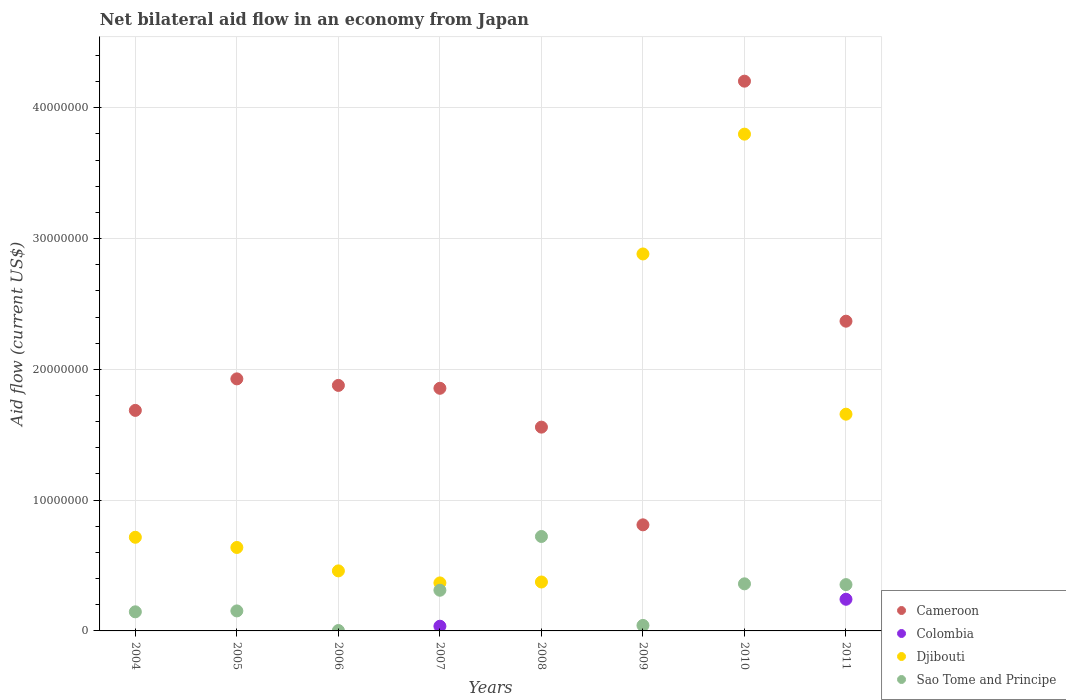Is the number of dotlines equal to the number of legend labels?
Your response must be concise. No. What is the net bilateral aid flow in Djibouti in 2005?
Give a very brief answer. 6.38e+06. Across all years, what is the maximum net bilateral aid flow in Djibouti?
Your answer should be compact. 3.80e+07. Across all years, what is the minimum net bilateral aid flow in Cameroon?
Provide a short and direct response. 8.11e+06. What is the total net bilateral aid flow in Cameroon in the graph?
Keep it short and to the point. 1.63e+08. What is the difference between the net bilateral aid flow in Djibouti in 2009 and that in 2010?
Keep it short and to the point. -9.16e+06. What is the difference between the net bilateral aid flow in Djibouti in 2005 and the net bilateral aid flow in Colombia in 2010?
Provide a succinct answer. 6.38e+06. What is the average net bilateral aid flow in Djibouti per year?
Offer a terse response. 1.36e+07. In the year 2006, what is the difference between the net bilateral aid flow in Djibouti and net bilateral aid flow in Cameroon?
Your response must be concise. -1.42e+07. What is the ratio of the net bilateral aid flow in Sao Tome and Principe in 2004 to that in 2005?
Make the answer very short. 0.95. Is the net bilateral aid flow in Sao Tome and Principe in 2010 less than that in 2011?
Offer a very short reply. No. What is the difference between the highest and the second highest net bilateral aid flow in Djibouti?
Offer a very short reply. 9.16e+06. What is the difference between the highest and the lowest net bilateral aid flow in Sao Tome and Principe?
Your answer should be compact. 7.19e+06. In how many years, is the net bilateral aid flow in Djibouti greater than the average net bilateral aid flow in Djibouti taken over all years?
Ensure brevity in your answer.  3. Is the sum of the net bilateral aid flow in Sao Tome and Principe in 2005 and 2009 greater than the maximum net bilateral aid flow in Cameroon across all years?
Ensure brevity in your answer.  No. Is it the case that in every year, the sum of the net bilateral aid flow in Cameroon and net bilateral aid flow in Djibouti  is greater than the sum of net bilateral aid flow in Sao Tome and Principe and net bilateral aid flow in Colombia?
Keep it short and to the point. No. Is it the case that in every year, the sum of the net bilateral aid flow in Colombia and net bilateral aid flow in Djibouti  is greater than the net bilateral aid flow in Sao Tome and Principe?
Your answer should be compact. No. Is the net bilateral aid flow in Sao Tome and Principe strictly less than the net bilateral aid flow in Cameroon over the years?
Offer a very short reply. Yes. Where does the legend appear in the graph?
Keep it short and to the point. Bottom right. What is the title of the graph?
Make the answer very short. Net bilateral aid flow in an economy from Japan. What is the label or title of the X-axis?
Offer a terse response. Years. What is the label or title of the Y-axis?
Offer a terse response. Aid flow (current US$). What is the Aid flow (current US$) in Cameroon in 2004?
Offer a terse response. 1.69e+07. What is the Aid flow (current US$) of Djibouti in 2004?
Offer a terse response. 7.16e+06. What is the Aid flow (current US$) of Sao Tome and Principe in 2004?
Provide a succinct answer. 1.46e+06. What is the Aid flow (current US$) in Cameroon in 2005?
Offer a terse response. 1.93e+07. What is the Aid flow (current US$) of Colombia in 2005?
Keep it short and to the point. 0. What is the Aid flow (current US$) in Djibouti in 2005?
Provide a short and direct response. 6.38e+06. What is the Aid flow (current US$) in Sao Tome and Principe in 2005?
Provide a succinct answer. 1.53e+06. What is the Aid flow (current US$) in Cameroon in 2006?
Keep it short and to the point. 1.88e+07. What is the Aid flow (current US$) of Colombia in 2006?
Give a very brief answer. 0. What is the Aid flow (current US$) in Djibouti in 2006?
Keep it short and to the point. 4.59e+06. What is the Aid flow (current US$) of Sao Tome and Principe in 2006?
Make the answer very short. 3.00e+04. What is the Aid flow (current US$) of Cameroon in 2007?
Your answer should be compact. 1.86e+07. What is the Aid flow (current US$) of Colombia in 2007?
Provide a succinct answer. 3.60e+05. What is the Aid flow (current US$) of Djibouti in 2007?
Give a very brief answer. 3.67e+06. What is the Aid flow (current US$) of Sao Tome and Principe in 2007?
Your answer should be compact. 3.11e+06. What is the Aid flow (current US$) in Cameroon in 2008?
Offer a very short reply. 1.56e+07. What is the Aid flow (current US$) of Colombia in 2008?
Offer a very short reply. 0. What is the Aid flow (current US$) in Djibouti in 2008?
Keep it short and to the point. 3.74e+06. What is the Aid flow (current US$) in Sao Tome and Principe in 2008?
Your response must be concise. 7.22e+06. What is the Aid flow (current US$) of Cameroon in 2009?
Make the answer very short. 8.11e+06. What is the Aid flow (current US$) in Colombia in 2009?
Give a very brief answer. 0. What is the Aid flow (current US$) in Djibouti in 2009?
Your response must be concise. 2.88e+07. What is the Aid flow (current US$) in Cameroon in 2010?
Ensure brevity in your answer.  4.20e+07. What is the Aid flow (current US$) in Djibouti in 2010?
Keep it short and to the point. 3.80e+07. What is the Aid flow (current US$) of Sao Tome and Principe in 2010?
Ensure brevity in your answer.  3.60e+06. What is the Aid flow (current US$) in Cameroon in 2011?
Keep it short and to the point. 2.37e+07. What is the Aid flow (current US$) in Colombia in 2011?
Offer a very short reply. 2.42e+06. What is the Aid flow (current US$) in Djibouti in 2011?
Offer a terse response. 1.66e+07. What is the Aid flow (current US$) in Sao Tome and Principe in 2011?
Give a very brief answer. 3.54e+06. Across all years, what is the maximum Aid flow (current US$) in Cameroon?
Your answer should be very brief. 4.20e+07. Across all years, what is the maximum Aid flow (current US$) of Colombia?
Keep it short and to the point. 2.42e+06. Across all years, what is the maximum Aid flow (current US$) in Djibouti?
Provide a short and direct response. 3.80e+07. Across all years, what is the maximum Aid flow (current US$) in Sao Tome and Principe?
Give a very brief answer. 7.22e+06. Across all years, what is the minimum Aid flow (current US$) of Cameroon?
Offer a very short reply. 8.11e+06. Across all years, what is the minimum Aid flow (current US$) of Colombia?
Provide a short and direct response. 0. Across all years, what is the minimum Aid flow (current US$) of Djibouti?
Give a very brief answer. 3.67e+06. What is the total Aid flow (current US$) in Cameroon in the graph?
Provide a short and direct response. 1.63e+08. What is the total Aid flow (current US$) of Colombia in the graph?
Your answer should be compact. 2.78e+06. What is the total Aid flow (current US$) in Djibouti in the graph?
Your response must be concise. 1.09e+08. What is the total Aid flow (current US$) of Sao Tome and Principe in the graph?
Offer a terse response. 2.09e+07. What is the difference between the Aid flow (current US$) in Cameroon in 2004 and that in 2005?
Keep it short and to the point. -2.41e+06. What is the difference between the Aid flow (current US$) of Djibouti in 2004 and that in 2005?
Give a very brief answer. 7.80e+05. What is the difference between the Aid flow (current US$) in Sao Tome and Principe in 2004 and that in 2005?
Ensure brevity in your answer.  -7.00e+04. What is the difference between the Aid flow (current US$) in Cameroon in 2004 and that in 2006?
Offer a very short reply. -1.91e+06. What is the difference between the Aid flow (current US$) of Djibouti in 2004 and that in 2006?
Make the answer very short. 2.57e+06. What is the difference between the Aid flow (current US$) of Sao Tome and Principe in 2004 and that in 2006?
Make the answer very short. 1.43e+06. What is the difference between the Aid flow (current US$) of Cameroon in 2004 and that in 2007?
Your answer should be very brief. -1.69e+06. What is the difference between the Aid flow (current US$) of Djibouti in 2004 and that in 2007?
Give a very brief answer. 3.49e+06. What is the difference between the Aid flow (current US$) in Sao Tome and Principe in 2004 and that in 2007?
Your answer should be very brief. -1.65e+06. What is the difference between the Aid flow (current US$) of Cameroon in 2004 and that in 2008?
Offer a very short reply. 1.28e+06. What is the difference between the Aid flow (current US$) of Djibouti in 2004 and that in 2008?
Ensure brevity in your answer.  3.42e+06. What is the difference between the Aid flow (current US$) in Sao Tome and Principe in 2004 and that in 2008?
Provide a succinct answer. -5.76e+06. What is the difference between the Aid flow (current US$) in Cameroon in 2004 and that in 2009?
Give a very brief answer. 8.75e+06. What is the difference between the Aid flow (current US$) of Djibouti in 2004 and that in 2009?
Keep it short and to the point. -2.17e+07. What is the difference between the Aid flow (current US$) of Sao Tome and Principe in 2004 and that in 2009?
Your response must be concise. 1.04e+06. What is the difference between the Aid flow (current US$) in Cameroon in 2004 and that in 2010?
Your response must be concise. -2.52e+07. What is the difference between the Aid flow (current US$) of Djibouti in 2004 and that in 2010?
Your answer should be very brief. -3.08e+07. What is the difference between the Aid flow (current US$) of Sao Tome and Principe in 2004 and that in 2010?
Offer a terse response. -2.14e+06. What is the difference between the Aid flow (current US$) of Cameroon in 2004 and that in 2011?
Offer a terse response. -6.82e+06. What is the difference between the Aid flow (current US$) of Djibouti in 2004 and that in 2011?
Your response must be concise. -9.41e+06. What is the difference between the Aid flow (current US$) in Sao Tome and Principe in 2004 and that in 2011?
Make the answer very short. -2.08e+06. What is the difference between the Aid flow (current US$) of Cameroon in 2005 and that in 2006?
Your response must be concise. 5.00e+05. What is the difference between the Aid flow (current US$) of Djibouti in 2005 and that in 2006?
Provide a short and direct response. 1.79e+06. What is the difference between the Aid flow (current US$) of Sao Tome and Principe in 2005 and that in 2006?
Ensure brevity in your answer.  1.50e+06. What is the difference between the Aid flow (current US$) of Cameroon in 2005 and that in 2007?
Offer a terse response. 7.20e+05. What is the difference between the Aid flow (current US$) in Djibouti in 2005 and that in 2007?
Ensure brevity in your answer.  2.71e+06. What is the difference between the Aid flow (current US$) of Sao Tome and Principe in 2005 and that in 2007?
Your response must be concise. -1.58e+06. What is the difference between the Aid flow (current US$) in Cameroon in 2005 and that in 2008?
Give a very brief answer. 3.69e+06. What is the difference between the Aid flow (current US$) in Djibouti in 2005 and that in 2008?
Offer a very short reply. 2.64e+06. What is the difference between the Aid flow (current US$) of Sao Tome and Principe in 2005 and that in 2008?
Provide a short and direct response. -5.69e+06. What is the difference between the Aid flow (current US$) in Cameroon in 2005 and that in 2009?
Make the answer very short. 1.12e+07. What is the difference between the Aid flow (current US$) in Djibouti in 2005 and that in 2009?
Offer a very short reply. -2.24e+07. What is the difference between the Aid flow (current US$) of Sao Tome and Principe in 2005 and that in 2009?
Ensure brevity in your answer.  1.11e+06. What is the difference between the Aid flow (current US$) of Cameroon in 2005 and that in 2010?
Provide a succinct answer. -2.28e+07. What is the difference between the Aid flow (current US$) of Djibouti in 2005 and that in 2010?
Ensure brevity in your answer.  -3.16e+07. What is the difference between the Aid flow (current US$) in Sao Tome and Principe in 2005 and that in 2010?
Provide a succinct answer. -2.07e+06. What is the difference between the Aid flow (current US$) of Cameroon in 2005 and that in 2011?
Provide a short and direct response. -4.41e+06. What is the difference between the Aid flow (current US$) in Djibouti in 2005 and that in 2011?
Offer a terse response. -1.02e+07. What is the difference between the Aid flow (current US$) in Sao Tome and Principe in 2005 and that in 2011?
Offer a terse response. -2.01e+06. What is the difference between the Aid flow (current US$) of Cameroon in 2006 and that in 2007?
Keep it short and to the point. 2.20e+05. What is the difference between the Aid flow (current US$) of Djibouti in 2006 and that in 2007?
Make the answer very short. 9.20e+05. What is the difference between the Aid flow (current US$) of Sao Tome and Principe in 2006 and that in 2007?
Your response must be concise. -3.08e+06. What is the difference between the Aid flow (current US$) of Cameroon in 2006 and that in 2008?
Offer a terse response. 3.19e+06. What is the difference between the Aid flow (current US$) of Djibouti in 2006 and that in 2008?
Make the answer very short. 8.50e+05. What is the difference between the Aid flow (current US$) of Sao Tome and Principe in 2006 and that in 2008?
Ensure brevity in your answer.  -7.19e+06. What is the difference between the Aid flow (current US$) in Cameroon in 2006 and that in 2009?
Provide a succinct answer. 1.07e+07. What is the difference between the Aid flow (current US$) in Djibouti in 2006 and that in 2009?
Offer a terse response. -2.42e+07. What is the difference between the Aid flow (current US$) in Sao Tome and Principe in 2006 and that in 2009?
Your response must be concise. -3.90e+05. What is the difference between the Aid flow (current US$) of Cameroon in 2006 and that in 2010?
Make the answer very short. -2.33e+07. What is the difference between the Aid flow (current US$) of Djibouti in 2006 and that in 2010?
Keep it short and to the point. -3.34e+07. What is the difference between the Aid flow (current US$) of Sao Tome and Principe in 2006 and that in 2010?
Keep it short and to the point. -3.57e+06. What is the difference between the Aid flow (current US$) of Cameroon in 2006 and that in 2011?
Make the answer very short. -4.91e+06. What is the difference between the Aid flow (current US$) in Djibouti in 2006 and that in 2011?
Your response must be concise. -1.20e+07. What is the difference between the Aid flow (current US$) of Sao Tome and Principe in 2006 and that in 2011?
Your answer should be very brief. -3.51e+06. What is the difference between the Aid flow (current US$) in Cameroon in 2007 and that in 2008?
Ensure brevity in your answer.  2.97e+06. What is the difference between the Aid flow (current US$) of Sao Tome and Principe in 2007 and that in 2008?
Offer a very short reply. -4.11e+06. What is the difference between the Aid flow (current US$) of Cameroon in 2007 and that in 2009?
Your answer should be very brief. 1.04e+07. What is the difference between the Aid flow (current US$) in Djibouti in 2007 and that in 2009?
Your answer should be very brief. -2.52e+07. What is the difference between the Aid flow (current US$) in Sao Tome and Principe in 2007 and that in 2009?
Give a very brief answer. 2.69e+06. What is the difference between the Aid flow (current US$) of Cameroon in 2007 and that in 2010?
Ensure brevity in your answer.  -2.35e+07. What is the difference between the Aid flow (current US$) in Djibouti in 2007 and that in 2010?
Your answer should be compact. -3.43e+07. What is the difference between the Aid flow (current US$) in Sao Tome and Principe in 2007 and that in 2010?
Make the answer very short. -4.90e+05. What is the difference between the Aid flow (current US$) of Cameroon in 2007 and that in 2011?
Your answer should be very brief. -5.13e+06. What is the difference between the Aid flow (current US$) of Colombia in 2007 and that in 2011?
Give a very brief answer. -2.06e+06. What is the difference between the Aid flow (current US$) of Djibouti in 2007 and that in 2011?
Give a very brief answer. -1.29e+07. What is the difference between the Aid flow (current US$) in Sao Tome and Principe in 2007 and that in 2011?
Provide a succinct answer. -4.30e+05. What is the difference between the Aid flow (current US$) in Cameroon in 2008 and that in 2009?
Your answer should be compact. 7.47e+06. What is the difference between the Aid flow (current US$) in Djibouti in 2008 and that in 2009?
Give a very brief answer. -2.51e+07. What is the difference between the Aid flow (current US$) in Sao Tome and Principe in 2008 and that in 2009?
Offer a very short reply. 6.80e+06. What is the difference between the Aid flow (current US$) in Cameroon in 2008 and that in 2010?
Offer a very short reply. -2.64e+07. What is the difference between the Aid flow (current US$) of Djibouti in 2008 and that in 2010?
Provide a short and direct response. -3.42e+07. What is the difference between the Aid flow (current US$) in Sao Tome and Principe in 2008 and that in 2010?
Provide a succinct answer. 3.62e+06. What is the difference between the Aid flow (current US$) in Cameroon in 2008 and that in 2011?
Provide a short and direct response. -8.10e+06. What is the difference between the Aid flow (current US$) in Djibouti in 2008 and that in 2011?
Offer a very short reply. -1.28e+07. What is the difference between the Aid flow (current US$) in Sao Tome and Principe in 2008 and that in 2011?
Keep it short and to the point. 3.68e+06. What is the difference between the Aid flow (current US$) of Cameroon in 2009 and that in 2010?
Make the answer very short. -3.39e+07. What is the difference between the Aid flow (current US$) in Djibouti in 2009 and that in 2010?
Make the answer very short. -9.16e+06. What is the difference between the Aid flow (current US$) of Sao Tome and Principe in 2009 and that in 2010?
Your answer should be compact. -3.18e+06. What is the difference between the Aid flow (current US$) in Cameroon in 2009 and that in 2011?
Your answer should be very brief. -1.56e+07. What is the difference between the Aid flow (current US$) in Djibouti in 2009 and that in 2011?
Ensure brevity in your answer.  1.22e+07. What is the difference between the Aid flow (current US$) in Sao Tome and Principe in 2009 and that in 2011?
Your response must be concise. -3.12e+06. What is the difference between the Aid flow (current US$) in Cameroon in 2010 and that in 2011?
Keep it short and to the point. 1.84e+07. What is the difference between the Aid flow (current US$) of Djibouti in 2010 and that in 2011?
Your response must be concise. 2.14e+07. What is the difference between the Aid flow (current US$) of Cameroon in 2004 and the Aid flow (current US$) of Djibouti in 2005?
Offer a terse response. 1.05e+07. What is the difference between the Aid flow (current US$) of Cameroon in 2004 and the Aid flow (current US$) of Sao Tome and Principe in 2005?
Your response must be concise. 1.53e+07. What is the difference between the Aid flow (current US$) of Djibouti in 2004 and the Aid flow (current US$) of Sao Tome and Principe in 2005?
Offer a very short reply. 5.63e+06. What is the difference between the Aid flow (current US$) in Cameroon in 2004 and the Aid flow (current US$) in Djibouti in 2006?
Offer a very short reply. 1.23e+07. What is the difference between the Aid flow (current US$) in Cameroon in 2004 and the Aid flow (current US$) in Sao Tome and Principe in 2006?
Your answer should be compact. 1.68e+07. What is the difference between the Aid flow (current US$) in Djibouti in 2004 and the Aid flow (current US$) in Sao Tome and Principe in 2006?
Make the answer very short. 7.13e+06. What is the difference between the Aid flow (current US$) of Cameroon in 2004 and the Aid flow (current US$) of Colombia in 2007?
Ensure brevity in your answer.  1.65e+07. What is the difference between the Aid flow (current US$) of Cameroon in 2004 and the Aid flow (current US$) of Djibouti in 2007?
Your answer should be very brief. 1.32e+07. What is the difference between the Aid flow (current US$) of Cameroon in 2004 and the Aid flow (current US$) of Sao Tome and Principe in 2007?
Make the answer very short. 1.38e+07. What is the difference between the Aid flow (current US$) in Djibouti in 2004 and the Aid flow (current US$) in Sao Tome and Principe in 2007?
Make the answer very short. 4.05e+06. What is the difference between the Aid flow (current US$) in Cameroon in 2004 and the Aid flow (current US$) in Djibouti in 2008?
Provide a short and direct response. 1.31e+07. What is the difference between the Aid flow (current US$) of Cameroon in 2004 and the Aid flow (current US$) of Sao Tome and Principe in 2008?
Offer a very short reply. 9.64e+06. What is the difference between the Aid flow (current US$) of Djibouti in 2004 and the Aid flow (current US$) of Sao Tome and Principe in 2008?
Provide a short and direct response. -6.00e+04. What is the difference between the Aid flow (current US$) of Cameroon in 2004 and the Aid flow (current US$) of Djibouti in 2009?
Your response must be concise. -1.20e+07. What is the difference between the Aid flow (current US$) of Cameroon in 2004 and the Aid flow (current US$) of Sao Tome and Principe in 2009?
Offer a very short reply. 1.64e+07. What is the difference between the Aid flow (current US$) of Djibouti in 2004 and the Aid flow (current US$) of Sao Tome and Principe in 2009?
Your answer should be very brief. 6.74e+06. What is the difference between the Aid flow (current US$) of Cameroon in 2004 and the Aid flow (current US$) of Djibouti in 2010?
Provide a short and direct response. -2.11e+07. What is the difference between the Aid flow (current US$) in Cameroon in 2004 and the Aid flow (current US$) in Sao Tome and Principe in 2010?
Provide a short and direct response. 1.33e+07. What is the difference between the Aid flow (current US$) in Djibouti in 2004 and the Aid flow (current US$) in Sao Tome and Principe in 2010?
Provide a short and direct response. 3.56e+06. What is the difference between the Aid flow (current US$) of Cameroon in 2004 and the Aid flow (current US$) of Colombia in 2011?
Your answer should be very brief. 1.44e+07. What is the difference between the Aid flow (current US$) of Cameroon in 2004 and the Aid flow (current US$) of Sao Tome and Principe in 2011?
Provide a succinct answer. 1.33e+07. What is the difference between the Aid flow (current US$) of Djibouti in 2004 and the Aid flow (current US$) of Sao Tome and Principe in 2011?
Provide a short and direct response. 3.62e+06. What is the difference between the Aid flow (current US$) in Cameroon in 2005 and the Aid flow (current US$) in Djibouti in 2006?
Make the answer very short. 1.47e+07. What is the difference between the Aid flow (current US$) of Cameroon in 2005 and the Aid flow (current US$) of Sao Tome and Principe in 2006?
Offer a very short reply. 1.92e+07. What is the difference between the Aid flow (current US$) of Djibouti in 2005 and the Aid flow (current US$) of Sao Tome and Principe in 2006?
Offer a very short reply. 6.35e+06. What is the difference between the Aid flow (current US$) in Cameroon in 2005 and the Aid flow (current US$) in Colombia in 2007?
Offer a very short reply. 1.89e+07. What is the difference between the Aid flow (current US$) of Cameroon in 2005 and the Aid flow (current US$) of Djibouti in 2007?
Ensure brevity in your answer.  1.56e+07. What is the difference between the Aid flow (current US$) in Cameroon in 2005 and the Aid flow (current US$) in Sao Tome and Principe in 2007?
Offer a very short reply. 1.62e+07. What is the difference between the Aid flow (current US$) in Djibouti in 2005 and the Aid flow (current US$) in Sao Tome and Principe in 2007?
Offer a terse response. 3.27e+06. What is the difference between the Aid flow (current US$) of Cameroon in 2005 and the Aid flow (current US$) of Djibouti in 2008?
Provide a succinct answer. 1.55e+07. What is the difference between the Aid flow (current US$) of Cameroon in 2005 and the Aid flow (current US$) of Sao Tome and Principe in 2008?
Make the answer very short. 1.20e+07. What is the difference between the Aid flow (current US$) in Djibouti in 2005 and the Aid flow (current US$) in Sao Tome and Principe in 2008?
Offer a very short reply. -8.40e+05. What is the difference between the Aid flow (current US$) in Cameroon in 2005 and the Aid flow (current US$) in Djibouti in 2009?
Your response must be concise. -9.55e+06. What is the difference between the Aid flow (current US$) in Cameroon in 2005 and the Aid flow (current US$) in Sao Tome and Principe in 2009?
Offer a terse response. 1.88e+07. What is the difference between the Aid flow (current US$) in Djibouti in 2005 and the Aid flow (current US$) in Sao Tome and Principe in 2009?
Your response must be concise. 5.96e+06. What is the difference between the Aid flow (current US$) in Cameroon in 2005 and the Aid flow (current US$) in Djibouti in 2010?
Make the answer very short. -1.87e+07. What is the difference between the Aid flow (current US$) of Cameroon in 2005 and the Aid flow (current US$) of Sao Tome and Principe in 2010?
Provide a short and direct response. 1.57e+07. What is the difference between the Aid flow (current US$) of Djibouti in 2005 and the Aid flow (current US$) of Sao Tome and Principe in 2010?
Ensure brevity in your answer.  2.78e+06. What is the difference between the Aid flow (current US$) in Cameroon in 2005 and the Aid flow (current US$) in Colombia in 2011?
Give a very brief answer. 1.68e+07. What is the difference between the Aid flow (current US$) of Cameroon in 2005 and the Aid flow (current US$) of Djibouti in 2011?
Give a very brief answer. 2.70e+06. What is the difference between the Aid flow (current US$) of Cameroon in 2005 and the Aid flow (current US$) of Sao Tome and Principe in 2011?
Your answer should be very brief. 1.57e+07. What is the difference between the Aid flow (current US$) in Djibouti in 2005 and the Aid flow (current US$) in Sao Tome and Principe in 2011?
Your response must be concise. 2.84e+06. What is the difference between the Aid flow (current US$) in Cameroon in 2006 and the Aid flow (current US$) in Colombia in 2007?
Your answer should be compact. 1.84e+07. What is the difference between the Aid flow (current US$) of Cameroon in 2006 and the Aid flow (current US$) of Djibouti in 2007?
Make the answer very short. 1.51e+07. What is the difference between the Aid flow (current US$) of Cameroon in 2006 and the Aid flow (current US$) of Sao Tome and Principe in 2007?
Provide a succinct answer. 1.57e+07. What is the difference between the Aid flow (current US$) in Djibouti in 2006 and the Aid flow (current US$) in Sao Tome and Principe in 2007?
Your response must be concise. 1.48e+06. What is the difference between the Aid flow (current US$) of Cameroon in 2006 and the Aid flow (current US$) of Djibouti in 2008?
Give a very brief answer. 1.50e+07. What is the difference between the Aid flow (current US$) of Cameroon in 2006 and the Aid flow (current US$) of Sao Tome and Principe in 2008?
Provide a succinct answer. 1.16e+07. What is the difference between the Aid flow (current US$) in Djibouti in 2006 and the Aid flow (current US$) in Sao Tome and Principe in 2008?
Keep it short and to the point. -2.63e+06. What is the difference between the Aid flow (current US$) of Cameroon in 2006 and the Aid flow (current US$) of Djibouti in 2009?
Keep it short and to the point. -1.00e+07. What is the difference between the Aid flow (current US$) in Cameroon in 2006 and the Aid flow (current US$) in Sao Tome and Principe in 2009?
Keep it short and to the point. 1.84e+07. What is the difference between the Aid flow (current US$) of Djibouti in 2006 and the Aid flow (current US$) of Sao Tome and Principe in 2009?
Give a very brief answer. 4.17e+06. What is the difference between the Aid flow (current US$) in Cameroon in 2006 and the Aid flow (current US$) in Djibouti in 2010?
Your answer should be very brief. -1.92e+07. What is the difference between the Aid flow (current US$) of Cameroon in 2006 and the Aid flow (current US$) of Sao Tome and Principe in 2010?
Make the answer very short. 1.52e+07. What is the difference between the Aid flow (current US$) of Djibouti in 2006 and the Aid flow (current US$) of Sao Tome and Principe in 2010?
Offer a terse response. 9.90e+05. What is the difference between the Aid flow (current US$) of Cameroon in 2006 and the Aid flow (current US$) of Colombia in 2011?
Offer a very short reply. 1.64e+07. What is the difference between the Aid flow (current US$) in Cameroon in 2006 and the Aid flow (current US$) in Djibouti in 2011?
Provide a succinct answer. 2.20e+06. What is the difference between the Aid flow (current US$) in Cameroon in 2006 and the Aid flow (current US$) in Sao Tome and Principe in 2011?
Ensure brevity in your answer.  1.52e+07. What is the difference between the Aid flow (current US$) in Djibouti in 2006 and the Aid flow (current US$) in Sao Tome and Principe in 2011?
Keep it short and to the point. 1.05e+06. What is the difference between the Aid flow (current US$) in Cameroon in 2007 and the Aid flow (current US$) in Djibouti in 2008?
Give a very brief answer. 1.48e+07. What is the difference between the Aid flow (current US$) of Cameroon in 2007 and the Aid flow (current US$) of Sao Tome and Principe in 2008?
Offer a very short reply. 1.13e+07. What is the difference between the Aid flow (current US$) in Colombia in 2007 and the Aid flow (current US$) in Djibouti in 2008?
Ensure brevity in your answer.  -3.38e+06. What is the difference between the Aid flow (current US$) in Colombia in 2007 and the Aid flow (current US$) in Sao Tome and Principe in 2008?
Offer a very short reply. -6.86e+06. What is the difference between the Aid flow (current US$) of Djibouti in 2007 and the Aid flow (current US$) of Sao Tome and Principe in 2008?
Your answer should be very brief. -3.55e+06. What is the difference between the Aid flow (current US$) of Cameroon in 2007 and the Aid flow (current US$) of Djibouti in 2009?
Your answer should be very brief. -1.03e+07. What is the difference between the Aid flow (current US$) of Cameroon in 2007 and the Aid flow (current US$) of Sao Tome and Principe in 2009?
Keep it short and to the point. 1.81e+07. What is the difference between the Aid flow (current US$) in Colombia in 2007 and the Aid flow (current US$) in Djibouti in 2009?
Offer a very short reply. -2.85e+07. What is the difference between the Aid flow (current US$) in Djibouti in 2007 and the Aid flow (current US$) in Sao Tome and Principe in 2009?
Your answer should be very brief. 3.25e+06. What is the difference between the Aid flow (current US$) of Cameroon in 2007 and the Aid flow (current US$) of Djibouti in 2010?
Your answer should be compact. -1.94e+07. What is the difference between the Aid flow (current US$) in Cameroon in 2007 and the Aid flow (current US$) in Sao Tome and Principe in 2010?
Give a very brief answer. 1.50e+07. What is the difference between the Aid flow (current US$) of Colombia in 2007 and the Aid flow (current US$) of Djibouti in 2010?
Make the answer very short. -3.76e+07. What is the difference between the Aid flow (current US$) of Colombia in 2007 and the Aid flow (current US$) of Sao Tome and Principe in 2010?
Provide a short and direct response. -3.24e+06. What is the difference between the Aid flow (current US$) in Cameroon in 2007 and the Aid flow (current US$) in Colombia in 2011?
Provide a short and direct response. 1.61e+07. What is the difference between the Aid flow (current US$) in Cameroon in 2007 and the Aid flow (current US$) in Djibouti in 2011?
Your answer should be compact. 1.98e+06. What is the difference between the Aid flow (current US$) in Cameroon in 2007 and the Aid flow (current US$) in Sao Tome and Principe in 2011?
Ensure brevity in your answer.  1.50e+07. What is the difference between the Aid flow (current US$) in Colombia in 2007 and the Aid flow (current US$) in Djibouti in 2011?
Offer a very short reply. -1.62e+07. What is the difference between the Aid flow (current US$) of Colombia in 2007 and the Aid flow (current US$) of Sao Tome and Principe in 2011?
Keep it short and to the point. -3.18e+06. What is the difference between the Aid flow (current US$) in Cameroon in 2008 and the Aid flow (current US$) in Djibouti in 2009?
Provide a short and direct response. -1.32e+07. What is the difference between the Aid flow (current US$) in Cameroon in 2008 and the Aid flow (current US$) in Sao Tome and Principe in 2009?
Your answer should be very brief. 1.52e+07. What is the difference between the Aid flow (current US$) of Djibouti in 2008 and the Aid flow (current US$) of Sao Tome and Principe in 2009?
Your answer should be compact. 3.32e+06. What is the difference between the Aid flow (current US$) of Cameroon in 2008 and the Aid flow (current US$) of Djibouti in 2010?
Give a very brief answer. -2.24e+07. What is the difference between the Aid flow (current US$) in Cameroon in 2008 and the Aid flow (current US$) in Sao Tome and Principe in 2010?
Your answer should be compact. 1.20e+07. What is the difference between the Aid flow (current US$) in Cameroon in 2008 and the Aid flow (current US$) in Colombia in 2011?
Your answer should be compact. 1.32e+07. What is the difference between the Aid flow (current US$) in Cameroon in 2008 and the Aid flow (current US$) in Djibouti in 2011?
Your answer should be compact. -9.90e+05. What is the difference between the Aid flow (current US$) of Cameroon in 2008 and the Aid flow (current US$) of Sao Tome and Principe in 2011?
Your answer should be compact. 1.20e+07. What is the difference between the Aid flow (current US$) of Cameroon in 2009 and the Aid flow (current US$) of Djibouti in 2010?
Provide a succinct answer. -2.99e+07. What is the difference between the Aid flow (current US$) of Cameroon in 2009 and the Aid flow (current US$) of Sao Tome and Principe in 2010?
Provide a short and direct response. 4.51e+06. What is the difference between the Aid flow (current US$) in Djibouti in 2009 and the Aid flow (current US$) in Sao Tome and Principe in 2010?
Keep it short and to the point. 2.52e+07. What is the difference between the Aid flow (current US$) in Cameroon in 2009 and the Aid flow (current US$) in Colombia in 2011?
Your response must be concise. 5.69e+06. What is the difference between the Aid flow (current US$) in Cameroon in 2009 and the Aid flow (current US$) in Djibouti in 2011?
Ensure brevity in your answer.  -8.46e+06. What is the difference between the Aid flow (current US$) in Cameroon in 2009 and the Aid flow (current US$) in Sao Tome and Principe in 2011?
Make the answer very short. 4.57e+06. What is the difference between the Aid flow (current US$) of Djibouti in 2009 and the Aid flow (current US$) of Sao Tome and Principe in 2011?
Provide a short and direct response. 2.53e+07. What is the difference between the Aid flow (current US$) of Cameroon in 2010 and the Aid flow (current US$) of Colombia in 2011?
Offer a terse response. 3.96e+07. What is the difference between the Aid flow (current US$) of Cameroon in 2010 and the Aid flow (current US$) of Djibouti in 2011?
Keep it short and to the point. 2.55e+07. What is the difference between the Aid flow (current US$) of Cameroon in 2010 and the Aid flow (current US$) of Sao Tome and Principe in 2011?
Keep it short and to the point. 3.85e+07. What is the difference between the Aid flow (current US$) in Djibouti in 2010 and the Aid flow (current US$) in Sao Tome and Principe in 2011?
Offer a very short reply. 3.44e+07. What is the average Aid flow (current US$) in Cameroon per year?
Your answer should be compact. 2.04e+07. What is the average Aid flow (current US$) of Colombia per year?
Your response must be concise. 3.48e+05. What is the average Aid flow (current US$) of Djibouti per year?
Your answer should be compact. 1.36e+07. What is the average Aid flow (current US$) of Sao Tome and Principe per year?
Provide a succinct answer. 2.61e+06. In the year 2004, what is the difference between the Aid flow (current US$) of Cameroon and Aid flow (current US$) of Djibouti?
Provide a short and direct response. 9.70e+06. In the year 2004, what is the difference between the Aid flow (current US$) in Cameroon and Aid flow (current US$) in Sao Tome and Principe?
Your response must be concise. 1.54e+07. In the year 2004, what is the difference between the Aid flow (current US$) in Djibouti and Aid flow (current US$) in Sao Tome and Principe?
Your response must be concise. 5.70e+06. In the year 2005, what is the difference between the Aid flow (current US$) in Cameroon and Aid flow (current US$) in Djibouti?
Keep it short and to the point. 1.29e+07. In the year 2005, what is the difference between the Aid flow (current US$) of Cameroon and Aid flow (current US$) of Sao Tome and Principe?
Ensure brevity in your answer.  1.77e+07. In the year 2005, what is the difference between the Aid flow (current US$) in Djibouti and Aid flow (current US$) in Sao Tome and Principe?
Make the answer very short. 4.85e+06. In the year 2006, what is the difference between the Aid flow (current US$) of Cameroon and Aid flow (current US$) of Djibouti?
Give a very brief answer. 1.42e+07. In the year 2006, what is the difference between the Aid flow (current US$) of Cameroon and Aid flow (current US$) of Sao Tome and Principe?
Keep it short and to the point. 1.87e+07. In the year 2006, what is the difference between the Aid flow (current US$) of Djibouti and Aid flow (current US$) of Sao Tome and Principe?
Keep it short and to the point. 4.56e+06. In the year 2007, what is the difference between the Aid flow (current US$) of Cameroon and Aid flow (current US$) of Colombia?
Your response must be concise. 1.82e+07. In the year 2007, what is the difference between the Aid flow (current US$) of Cameroon and Aid flow (current US$) of Djibouti?
Ensure brevity in your answer.  1.49e+07. In the year 2007, what is the difference between the Aid flow (current US$) of Cameroon and Aid flow (current US$) of Sao Tome and Principe?
Offer a terse response. 1.54e+07. In the year 2007, what is the difference between the Aid flow (current US$) of Colombia and Aid flow (current US$) of Djibouti?
Your answer should be very brief. -3.31e+06. In the year 2007, what is the difference between the Aid flow (current US$) in Colombia and Aid flow (current US$) in Sao Tome and Principe?
Your answer should be very brief. -2.75e+06. In the year 2007, what is the difference between the Aid flow (current US$) of Djibouti and Aid flow (current US$) of Sao Tome and Principe?
Make the answer very short. 5.60e+05. In the year 2008, what is the difference between the Aid flow (current US$) of Cameroon and Aid flow (current US$) of Djibouti?
Offer a very short reply. 1.18e+07. In the year 2008, what is the difference between the Aid flow (current US$) of Cameroon and Aid flow (current US$) of Sao Tome and Principe?
Keep it short and to the point. 8.36e+06. In the year 2008, what is the difference between the Aid flow (current US$) of Djibouti and Aid flow (current US$) of Sao Tome and Principe?
Your answer should be very brief. -3.48e+06. In the year 2009, what is the difference between the Aid flow (current US$) in Cameroon and Aid flow (current US$) in Djibouti?
Make the answer very short. -2.07e+07. In the year 2009, what is the difference between the Aid flow (current US$) in Cameroon and Aid flow (current US$) in Sao Tome and Principe?
Give a very brief answer. 7.69e+06. In the year 2009, what is the difference between the Aid flow (current US$) of Djibouti and Aid flow (current US$) of Sao Tome and Principe?
Your response must be concise. 2.84e+07. In the year 2010, what is the difference between the Aid flow (current US$) in Cameroon and Aid flow (current US$) in Djibouti?
Provide a succinct answer. 4.05e+06. In the year 2010, what is the difference between the Aid flow (current US$) of Cameroon and Aid flow (current US$) of Sao Tome and Principe?
Offer a very short reply. 3.84e+07. In the year 2010, what is the difference between the Aid flow (current US$) in Djibouti and Aid flow (current US$) in Sao Tome and Principe?
Make the answer very short. 3.44e+07. In the year 2011, what is the difference between the Aid flow (current US$) in Cameroon and Aid flow (current US$) in Colombia?
Keep it short and to the point. 2.13e+07. In the year 2011, what is the difference between the Aid flow (current US$) in Cameroon and Aid flow (current US$) in Djibouti?
Your answer should be very brief. 7.11e+06. In the year 2011, what is the difference between the Aid flow (current US$) of Cameroon and Aid flow (current US$) of Sao Tome and Principe?
Give a very brief answer. 2.01e+07. In the year 2011, what is the difference between the Aid flow (current US$) of Colombia and Aid flow (current US$) of Djibouti?
Make the answer very short. -1.42e+07. In the year 2011, what is the difference between the Aid flow (current US$) in Colombia and Aid flow (current US$) in Sao Tome and Principe?
Give a very brief answer. -1.12e+06. In the year 2011, what is the difference between the Aid flow (current US$) of Djibouti and Aid flow (current US$) of Sao Tome and Principe?
Provide a succinct answer. 1.30e+07. What is the ratio of the Aid flow (current US$) of Cameroon in 2004 to that in 2005?
Provide a short and direct response. 0.87. What is the ratio of the Aid flow (current US$) of Djibouti in 2004 to that in 2005?
Offer a very short reply. 1.12. What is the ratio of the Aid flow (current US$) in Sao Tome and Principe in 2004 to that in 2005?
Offer a very short reply. 0.95. What is the ratio of the Aid flow (current US$) in Cameroon in 2004 to that in 2006?
Your answer should be very brief. 0.9. What is the ratio of the Aid flow (current US$) of Djibouti in 2004 to that in 2006?
Your response must be concise. 1.56. What is the ratio of the Aid flow (current US$) of Sao Tome and Principe in 2004 to that in 2006?
Provide a short and direct response. 48.67. What is the ratio of the Aid flow (current US$) in Cameroon in 2004 to that in 2007?
Give a very brief answer. 0.91. What is the ratio of the Aid flow (current US$) of Djibouti in 2004 to that in 2007?
Offer a very short reply. 1.95. What is the ratio of the Aid flow (current US$) of Sao Tome and Principe in 2004 to that in 2007?
Provide a short and direct response. 0.47. What is the ratio of the Aid flow (current US$) of Cameroon in 2004 to that in 2008?
Your response must be concise. 1.08. What is the ratio of the Aid flow (current US$) in Djibouti in 2004 to that in 2008?
Your response must be concise. 1.91. What is the ratio of the Aid flow (current US$) of Sao Tome and Principe in 2004 to that in 2008?
Ensure brevity in your answer.  0.2. What is the ratio of the Aid flow (current US$) in Cameroon in 2004 to that in 2009?
Your answer should be compact. 2.08. What is the ratio of the Aid flow (current US$) in Djibouti in 2004 to that in 2009?
Provide a short and direct response. 0.25. What is the ratio of the Aid flow (current US$) in Sao Tome and Principe in 2004 to that in 2009?
Ensure brevity in your answer.  3.48. What is the ratio of the Aid flow (current US$) in Cameroon in 2004 to that in 2010?
Ensure brevity in your answer.  0.4. What is the ratio of the Aid flow (current US$) in Djibouti in 2004 to that in 2010?
Offer a terse response. 0.19. What is the ratio of the Aid flow (current US$) of Sao Tome and Principe in 2004 to that in 2010?
Your response must be concise. 0.41. What is the ratio of the Aid flow (current US$) of Cameroon in 2004 to that in 2011?
Offer a terse response. 0.71. What is the ratio of the Aid flow (current US$) of Djibouti in 2004 to that in 2011?
Provide a short and direct response. 0.43. What is the ratio of the Aid flow (current US$) of Sao Tome and Principe in 2004 to that in 2011?
Make the answer very short. 0.41. What is the ratio of the Aid flow (current US$) in Cameroon in 2005 to that in 2006?
Make the answer very short. 1.03. What is the ratio of the Aid flow (current US$) in Djibouti in 2005 to that in 2006?
Your response must be concise. 1.39. What is the ratio of the Aid flow (current US$) of Cameroon in 2005 to that in 2007?
Your response must be concise. 1.04. What is the ratio of the Aid flow (current US$) in Djibouti in 2005 to that in 2007?
Ensure brevity in your answer.  1.74. What is the ratio of the Aid flow (current US$) in Sao Tome and Principe in 2005 to that in 2007?
Your answer should be very brief. 0.49. What is the ratio of the Aid flow (current US$) of Cameroon in 2005 to that in 2008?
Your answer should be compact. 1.24. What is the ratio of the Aid flow (current US$) in Djibouti in 2005 to that in 2008?
Ensure brevity in your answer.  1.71. What is the ratio of the Aid flow (current US$) in Sao Tome and Principe in 2005 to that in 2008?
Your answer should be very brief. 0.21. What is the ratio of the Aid flow (current US$) in Cameroon in 2005 to that in 2009?
Your answer should be compact. 2.38. What is the ratio of the Aid flow (current US$) of Djibouti in 2005 to that in 2009?
Offer a terse response. 0.22. What is the ratio of the Aid flow (current US$) of Sao Tome and Principe in 2005 to that in 2009?
Offer a terse response. 3.64. What is the ratio of the Aid flow (current US$) in Cameroon in 2005 to that in 2010?
Keep it short and to the point. 0.46. What is the ratio of the Aid flow (current US$) of Djibouti in 2005 to that in 2010?
Ensure brevity in your answer.  0.17. What is the ratio of the Aid flow (current US$) of Sao Tome and Principe in 2005 to that in 2010?
Give a very brief answer. 0.42. What is the ratio of the Aid flow (current US$) in Cameroon in 2005 to that in 2011?
Your response must be concise. 0.81. What is the ratio of the Aid flow (current US$) of Djibouti in 2005 to that in 2011?
Give a very brief answer. 0.39. What is the ratio of the Aid flow (current US$) in Sao Tome and Principe in 2005 to that in 2011?
Make the answer very short. 0.43. What is the ratio of the Aid flow (current US$) of Cameroon in 2006 to that in 2007?
Provide a short and direct response. 1.01. What is the ratio of the Aid flow (current US$) of Djibouti in 2006 to that in 2007?
Offer a terse response. 1.25. What is the ratio of the Aid flow (current US$) in Sao Tome and Principe in 2006 to that in 2007?
Your answer should be very brief. 0.01. What is the ratio of the Aid flow (current US$) in Cameroon in 2006 to that in 2008?
Your answer should be compact. 1.2. What is the ratio of the Aid flow (current US$) of Djibouti in 2006 to that in 2008?
Ensure brevity in your answer.  1.23. What is the ratio of the Aid flow (current US$) of Sao Tome and Principe in 2006 to that in 2008?
Your answer should be very brief. 0. What is the ratio of the Aid flow (current US$) of Cameroon in 2006 to that in 2009?
Provide a succinct answer. 2.31. What is the ratio of the Aid flow (current US$) of Djibouti in 2006 to that in 2009?
Offer a terse response. 0.16. What is the ratio of the Aid flow (current US$) of Sao Tome and Principe in 2006 to that in 2009?
Give a very brief answer. 0.07. What is the ratio of the Aid flow (current US$) of Cameroon in 2006 to that in 2010?
Your answer should be compact. 0.45. What is the ratio of the Aid flow (current US$) of Djibouti in 2006 to that in 2010?
Give a very brief answer. 0.12. What is the ratio of the Aid flow (current US$) in Sao Tome and Principe in 2006 to that in 2010?
Offer a very short reply. 0.01. What is the ratio of the Aid flow (current US$) of Cameroon in 2006 to that in 2011?
Provide a short and direct response. 0.79. What is the ratio of the Aid flow (current US$) in Djibouti in 2006 to that in 2011?
Offer a terse response. 0.28. What is the ratio of the Aid flow (current US$) in Sao Tome and Principe in 2006 to that in 2011?
Your response must be concise. 0.01. What is the ratio of the Aid flow (current US$) of Cameroon in 2007 to that in 2008?
Your answer should be compact. 1.19. What is the ratio of the Aid flow (current US$) of Djibouti in 2007 to that in 2008?
Keep it short and to the point. 0.98. What is the ratio of the Aid flow (current US$) of Sao Tome and Principe in 2007 to that in 2008?
Give a very brief answer. 0.43. What is the ratio of the Aid flow (current US$) of Cameroon in 2007 to that in 2009?
Your answer should be compact. 2.29. What is the ratio of the Aid flow (current US$) in Djibouti in 2007 to that in 2009?
Make the answer very short. 0.13. What is the ratio of the Aid flow (current US$) of Sao Tome and Principe in 2007 to that in 2009?
Provide a succinct answer. 7.4. What is the ratio of the Aid flow (current US$) of Cameroon in 2007 to that in 2010?
Your answer should be compact. 0.44. What is the ratio of the Aid flow (current US$) in Djibouti in 2007 to that in 2010?
Provide a short and direct response. 0.1. What is the ratio of the Aid flow (current US$) of Sao Tome and Principe in 2007 to that in 2010?
Offer a very short reply. 0.86. What is the ratio of the Aid flow (current US$) in Cameroon in 2007 to that in 2011?
Your answer should be very brief. 0.78. What is the ratio of the Aid flow (current US$) of Colombia in 2007 to that in 2011?
Provide a short and direct response. 0.15. What is the ratio of the Aid flow (current US$) in Djibouti in 2007 to that in 2011?
Make the answer very short. 0.22. What is the ratio of the Aid flow (current US$) in Sao Tome and Principe in 2007 to that in 2011?
Provide a short and direct response. 0.88. What is the ratio of the Aid flow (current US$) in Cameroon in 2008 to that in 2009?
Your answer should be very brief. 1.92. What is the ratio of the Aid flow (current US$) in Djibouti in 2008 to that in 2009?
Offer a very short reply. 0.13. What is the ratio of the Aid flow (current US$) of Sao Tome and Principe in 2008 to that in 2009?
Provide a short and direct response. 17.19. What is the ratio of the Aid flow (current US$) of Cameroon in 2008 to that in 2010?
Offer a very short reply. 0.37. What is the ratio of the Aid flow (current US$) in Djibouti in 2008 to that in 2010?
Offer a terse response. 0.1. What is the ratio of the Aid flow (current US$) in Sao Tome and Principe in 2008 to that in 2010?
Make the answer very short. 2.01. What is the ratio of the Aid flow (current US$) in Cameroon in 2008 to that in 2011?
Your answer should be compact. 0.66. What is the ratio of the Aid flow (current US$) in Djibouti in 2008 to that in 2011?
Provide a succinct answer. 0.23. What is the ratio of the Aid flow (current US$) of Sao Tome and Principe in 2008 to that in 2011?
Make the answer very short. 2.04. What is the ratio of the Aid flow (current US$) of Cameroon in 2009 to that in 2010?
Give a very brief answer. 0.19. What is the ratio of the Aid flow (current US$) of Djibouti in 2009 to that in 2010?
Give a very brief answer. 0.76. What is the ratio of the Aid flow (current US$) of Sao Tome and Principe in 2009 to that in 2010?
Offer a very short reply. 0.12. What is the ratio of the Aid flow (current US$) in Cameroon in 2009 to that in 2011?
Your answer should be compact. 0.34. What is the ratio of the Aid flow (current US$) of Djibouti in 2009 to that in 2011?
Offer a terse response. 1.74. What is the ratio of the Aid flow (current US$) in Sao Tome and Principe in 2009 to that in 2011?
Your answer should be very brief. 0.12. What is the ratio of the Aid flow (current US$) in Cameroon in 2010 to that in 2011?
Keep it short and to the point. 1.77. What is the ratio of the Aid flow (current US$) of Djibouti in 2010 to that in 2011?
Offer a terse response. 2.29. What is the ratio of the Aid flow (current US$) of Sao Tome and Principe in 2010 to that in 2011?
Your answer should be compact. 1.02. What is the difference between the highest and the second highest Aid flow (current US$) of Cameroon?
Offer a very short reply. 1.84e+07. What is the difference between the highest and the second highest Aid flow (current US$) in Djibouti?
Offer a very short reply. 9.16e+06. What is the difference between the highest and the second highest Aid flow (current US$) in Sao Tome and Principe?
Your answer should be compact. 3.62e+06. What is the difference between the highest and the lowest Aid flow (current US$) in Cameroon?
Provide a short and direct response. 3.39e+07. What is the difference between the highest and the lowest Aid flow (current US$) of Colombia?
Provide a short and direct response. 2.42e+06. What is the difference between the highest and the lowest Aid flow (current US$) of Djibouti?
Keep it short and to the point. 3.43e+07. What is the difference between the highest and the lowest Aid flow (current US$) in Sao Tome and Principe?
Offer a terse response. 7.19e+06. 